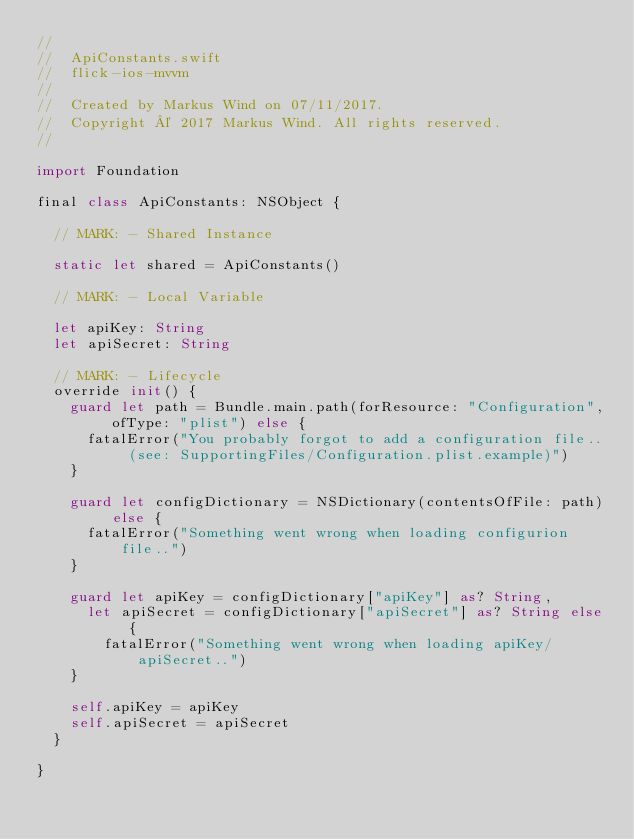<code> <loc_0><loc_0><loc_500><loc_500><_Swift_>//
//  ApiConstants.swift
//  flick-ios-mvvm
//
//  Created by Markus Wind on 07/11/2017.
//  Copyright © 2017 Markus Wind. All rights reserved.
//

import Foundation

final class ApiConstants: NSObject {

  // MARK: - Shared Instance

  static let shared = ApiConstants()

  // MARK: - Local Variable

  let apiKey: String
  let apiSecret: String

  // MARK: - Lifecycle
  override init() {
    guard let path = Bundle.main.path(forResource: "Configuration", ofType: "plist") else {
      fatalError("You probably forgot to add a configuration file.. (see: SupportingFiles/Configuration.plist.example)")
    }

    guard let configDictionary = NSDictionary(contentsOfFile: path) else {
      fatalError("Something went wrong when loading configurion file..")
    }

    guard let apiKey = configDictionary["apiKey"] as? String,
      let apiSecret = configDictionary["apiSecret"] as? String else {
        fatalError("Something went wrong when loading apiKey/apiSecret..")
    }

    self.apiKey = apiKey
    self.apiSecret = apiSecret
  }

}
</code> 